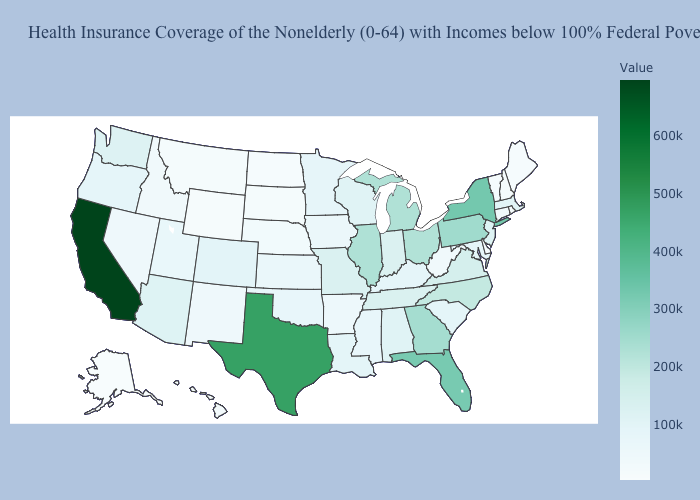Which states have the highest value in the USA?
Quick response, please. California. Among the states that border Alabama , which have the lowest value?
Answer briefly. Mississippi. Does the map have missing data?
Keep it brief. No. 